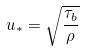<formula> <loc_0><loc_0><loc_500><loc_500>u _ { * } = \sqrt { \frac { \tau _ { b } } { \rho } }</formula> 